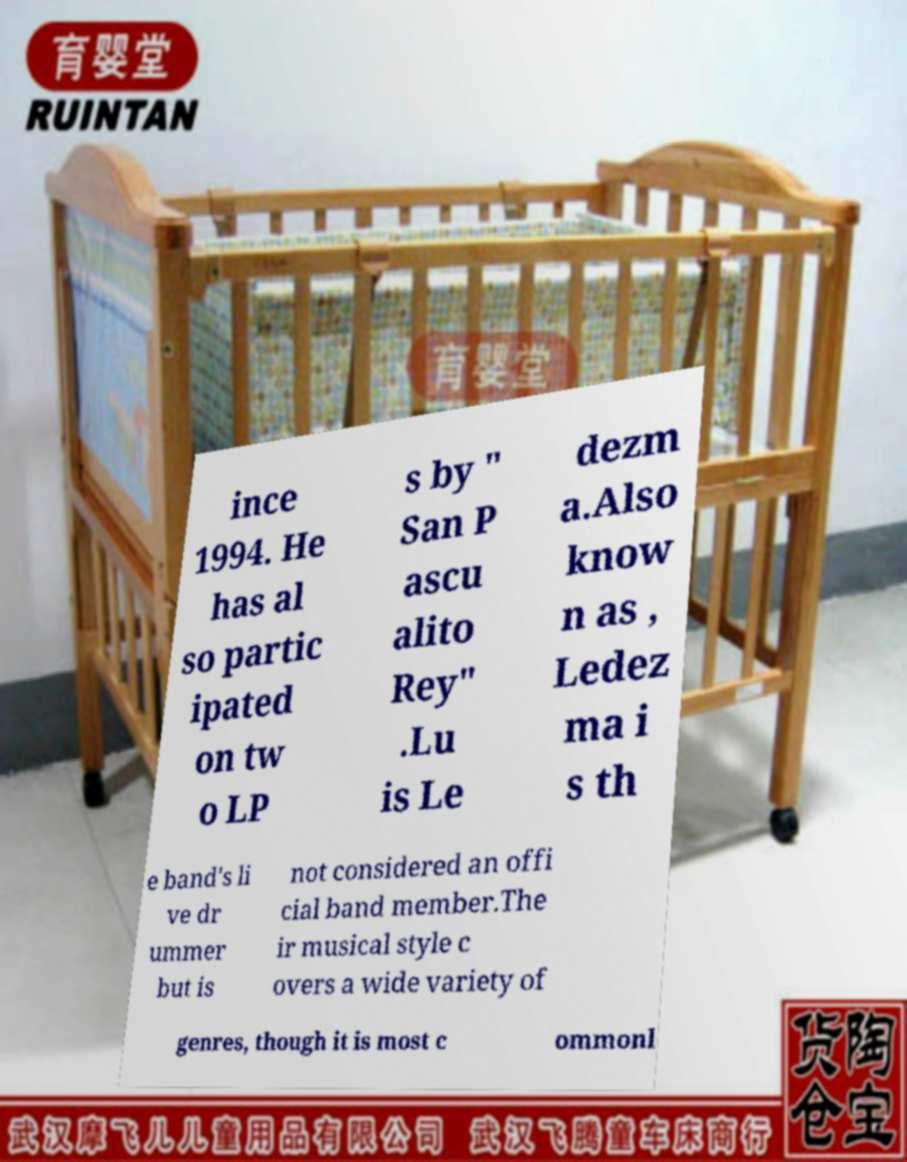Could you assist in decoding the text presented in this image and type it out clearly? ince 1994. He has al so partic ipated on tw o LP s by " San P ascu alito Rey" .Lu is Le dezm a.Also know n as , Ledez ma i s th e band's li ve dr ummer but is not considered an offi cial band member.The ir musical style c overs a wide variety of genres, though it is most c ommonl 